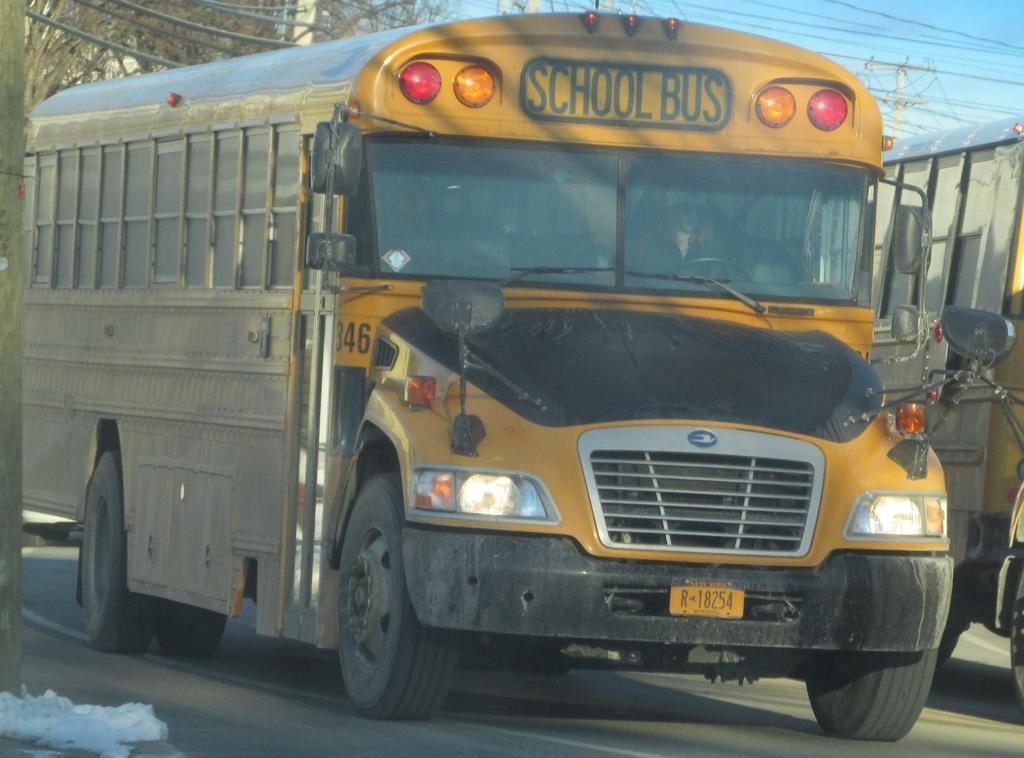In one or two sentences, can you explain what this image depicts? In this image there are vehicles on the road. In the background of the image there are current polls, trees and sky. On the left side of the image there is a pole. 